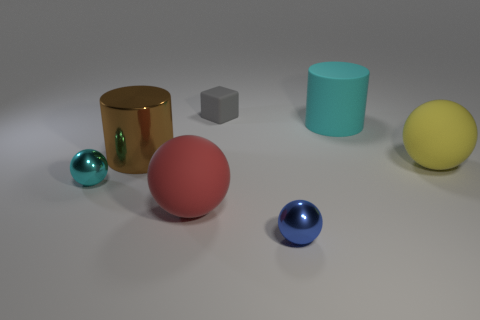What number of things are either matte things that are left of the blue ball or big objects behind the yellow thing?
Your answer should be very brief. 4. Do the cylinder to the left of the rubber cube and the tiny blue sphere have the same material?
Ensure brevity in your answer.  Yes. What material is the tiny object that is left of the small blue sphere and in front of the tiny matte cube?
Offer a very short reply. Metal. There is a big sphere right of the cyan thing that is right of the small cyan sphere; what is its color?
Provide a short and direct response. Yellow. What material is the blue thing that is the same shape as the tiny cyan thing?
Offer a terse response. Metal. The metal object left of the brown cylinder in front of the big cylinder that is right of the tiny gray object is what color?
Your answer should be very brief. Cyan. What number of things are purple spheres or metal things?
Make the answer very short. 3. What number of yellow things have the same shape as the gray matte thing?
Your answer should be very brief. 0. Do the large cyan thing and the small object to the right of the small gray thing have the same material?
Your answer should be very brief. No. What is the size of the cyan cylinder that is made of the same material as the small cube?
Make the answer very short. Large. 